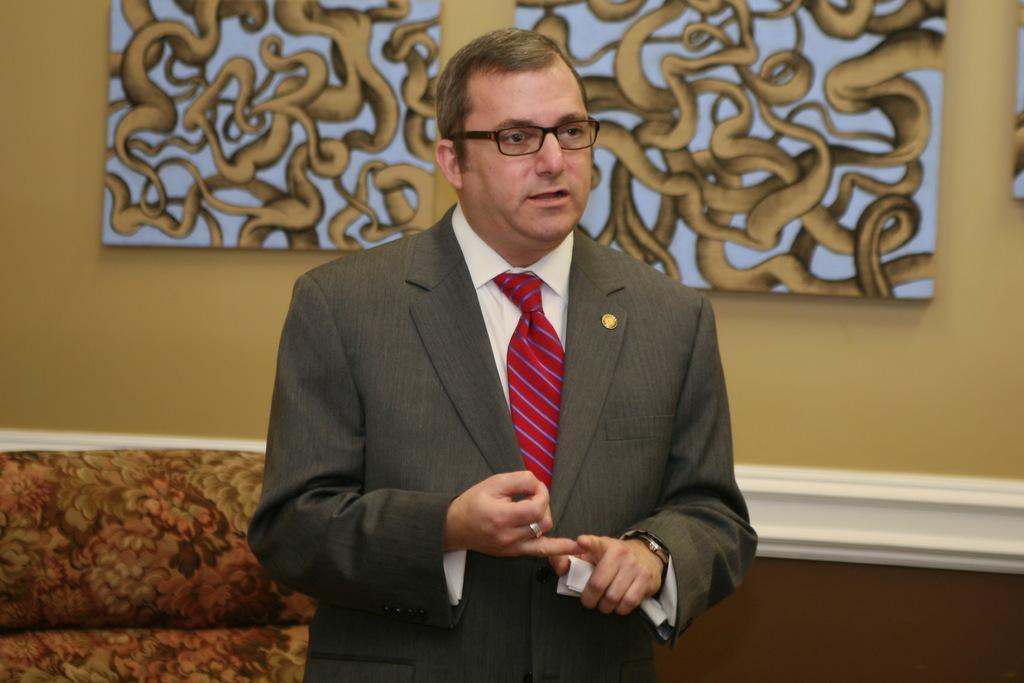How would you summarize this image in a sentence or two? In this picture we can see a man, he wore spectacles, behind to him we can find few paintings on the wall. 